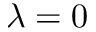<formula> <loc_0><loc_0><loc_500><loc_500>\lambda = 0</formula> 